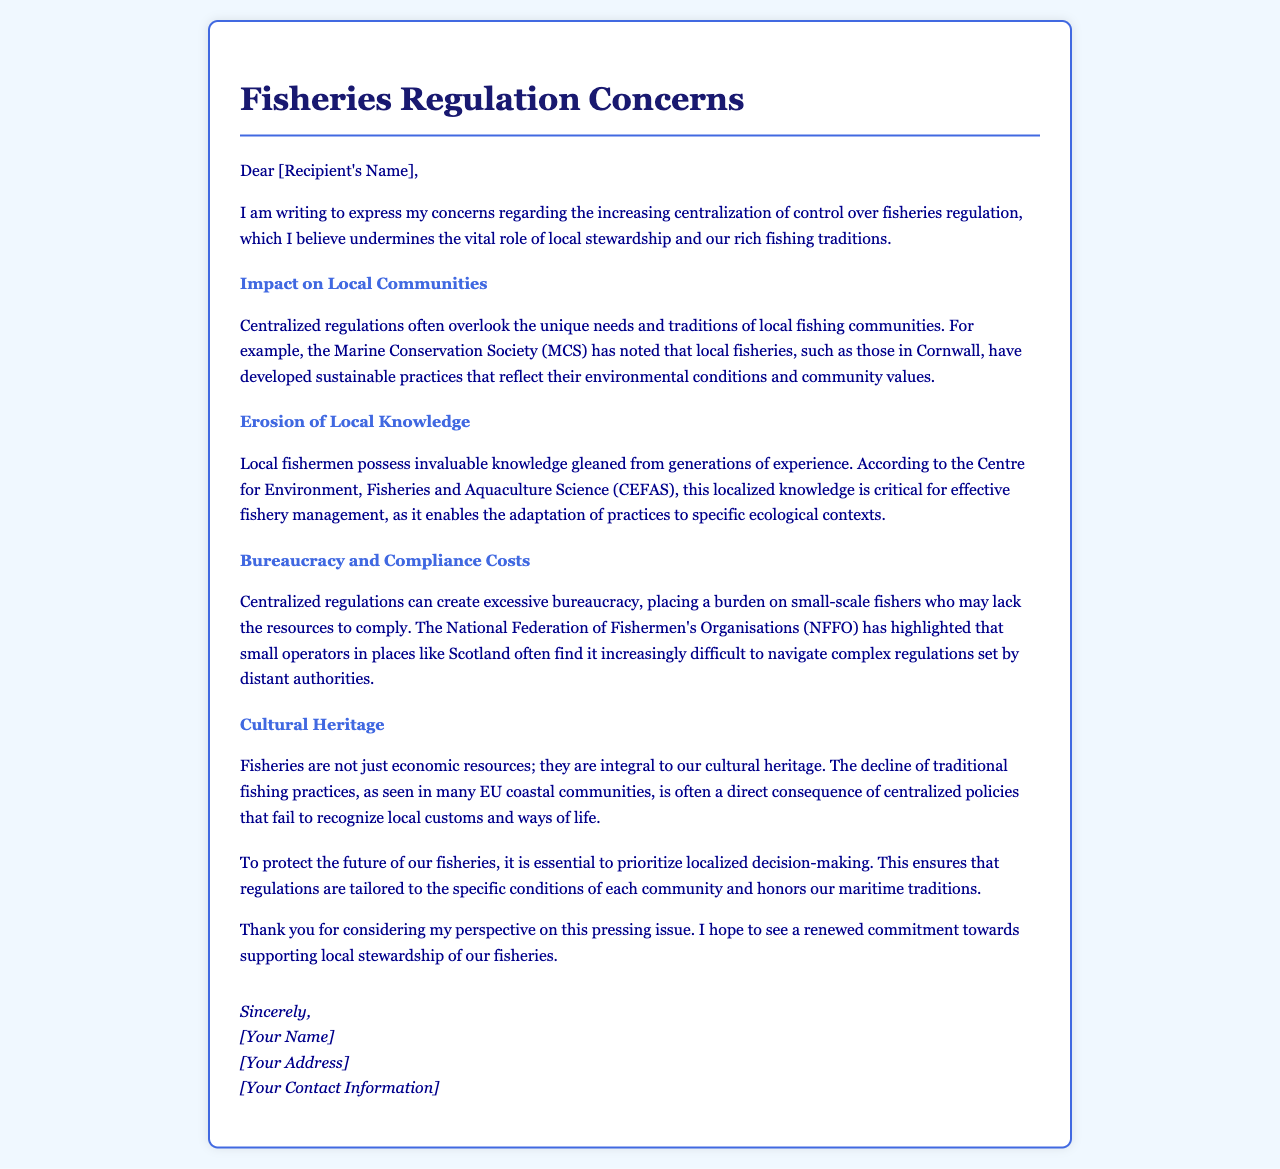What is the main concern expressed in the letter? The main concern is about the increasing centralization of control over fisheries regulation.
Answer: Centralization Which organization noted sustainable practices in local fisheries? The organization mentioned in the document is the Marine Conservation Society.
Answer: Marine Conservation Society What does CEFAS stand for? The acronym CEFAS in the document stands for the Centre for Environment, Fisheries and Aquaculture Science.
Answer: Centre for Environment, Fisheries and Aquaculture Science What cultural aspect is highlighted in relation to fisheries? The document emphasizes the fisheries' integral role in cultural heritage.
Answer: Cultural heritage What is mentioned as a burden for small-scale fishers? The document states that excessive bureaucracy creates a burden on small-scale fishers.
Answer: Bureaucracy Which region's small operators are mentioned as struggling with regulations? The document mentions small operators in Scotland as finding it difficult to navigate regulations.
Answer: Scotland What is essential to protect the future of fisheries, according to the letter? According to the letter, prioritizing localized decision-making is essential to protect fisheries.
Answer: Localized decision-making What does the letter suggest is a consequence of centralized policies? The letter states that centralized policies lead to the decline of traditional fishing practices.
Answer: Decline of traditional fishing practices Who is the letter addressed to? The letter is addressed to a recipient whose name is not specified.
Answer: [Recipient's Name] 